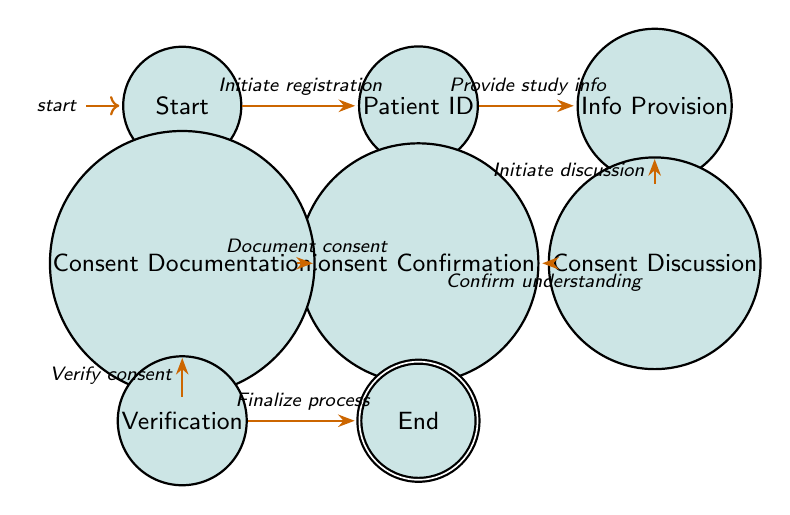What is the initial state of the diagram? The diagram starts at the "Start" state, which is indicated as the initial state in the diagram.
Answer: Start How many states are present in the diagram? By counting each distinct state listed in the diagram, we find there are a total of 8 states.
Answer: 8 What is the action leading from "Patient Identification" to "Information Provision"? The transition action between these two states is labeled "Provide study information," which facilitates the flow from identifying the patient to providing necessary study details.
Answer: Provide study information Which state comes after "Consent Confirmation"? The state that immediately follows "Consent Confirmation" is "Consent Documentation," as shown by the direct transition between these two states in the diagram.
Answer: Consent Documentation What is the last action taken in the process? The final action in the process, as represented in the diagram, is "Finalize process," which concludes the consent gathering workflow after all prior steps are completed.
Answer: Finalize process How many transitions are there in total? Each connection between states is a transition; counting these from the diagram shows there are 7 transitions in total.
Answer: 7 What is the relationship between "Consent Discussion" and "Consent Confirmation"? The relationship is defined by the transition action "Confirm patient's understanding and willingness," indicating a dialogue that ensures the patient is informed before consenting.
Answer: Confirm patient's understanding and willingness What state indicates the completion of the consent process? The "End" state signifies the completion of the entire consent process in the diagram.
Answer: End What is the first action taken in the consent process? The first action initiated is "Initiate patient registration," which opens the process by identifying the patient before proceeding further.
Answer: Initiate patient registration 